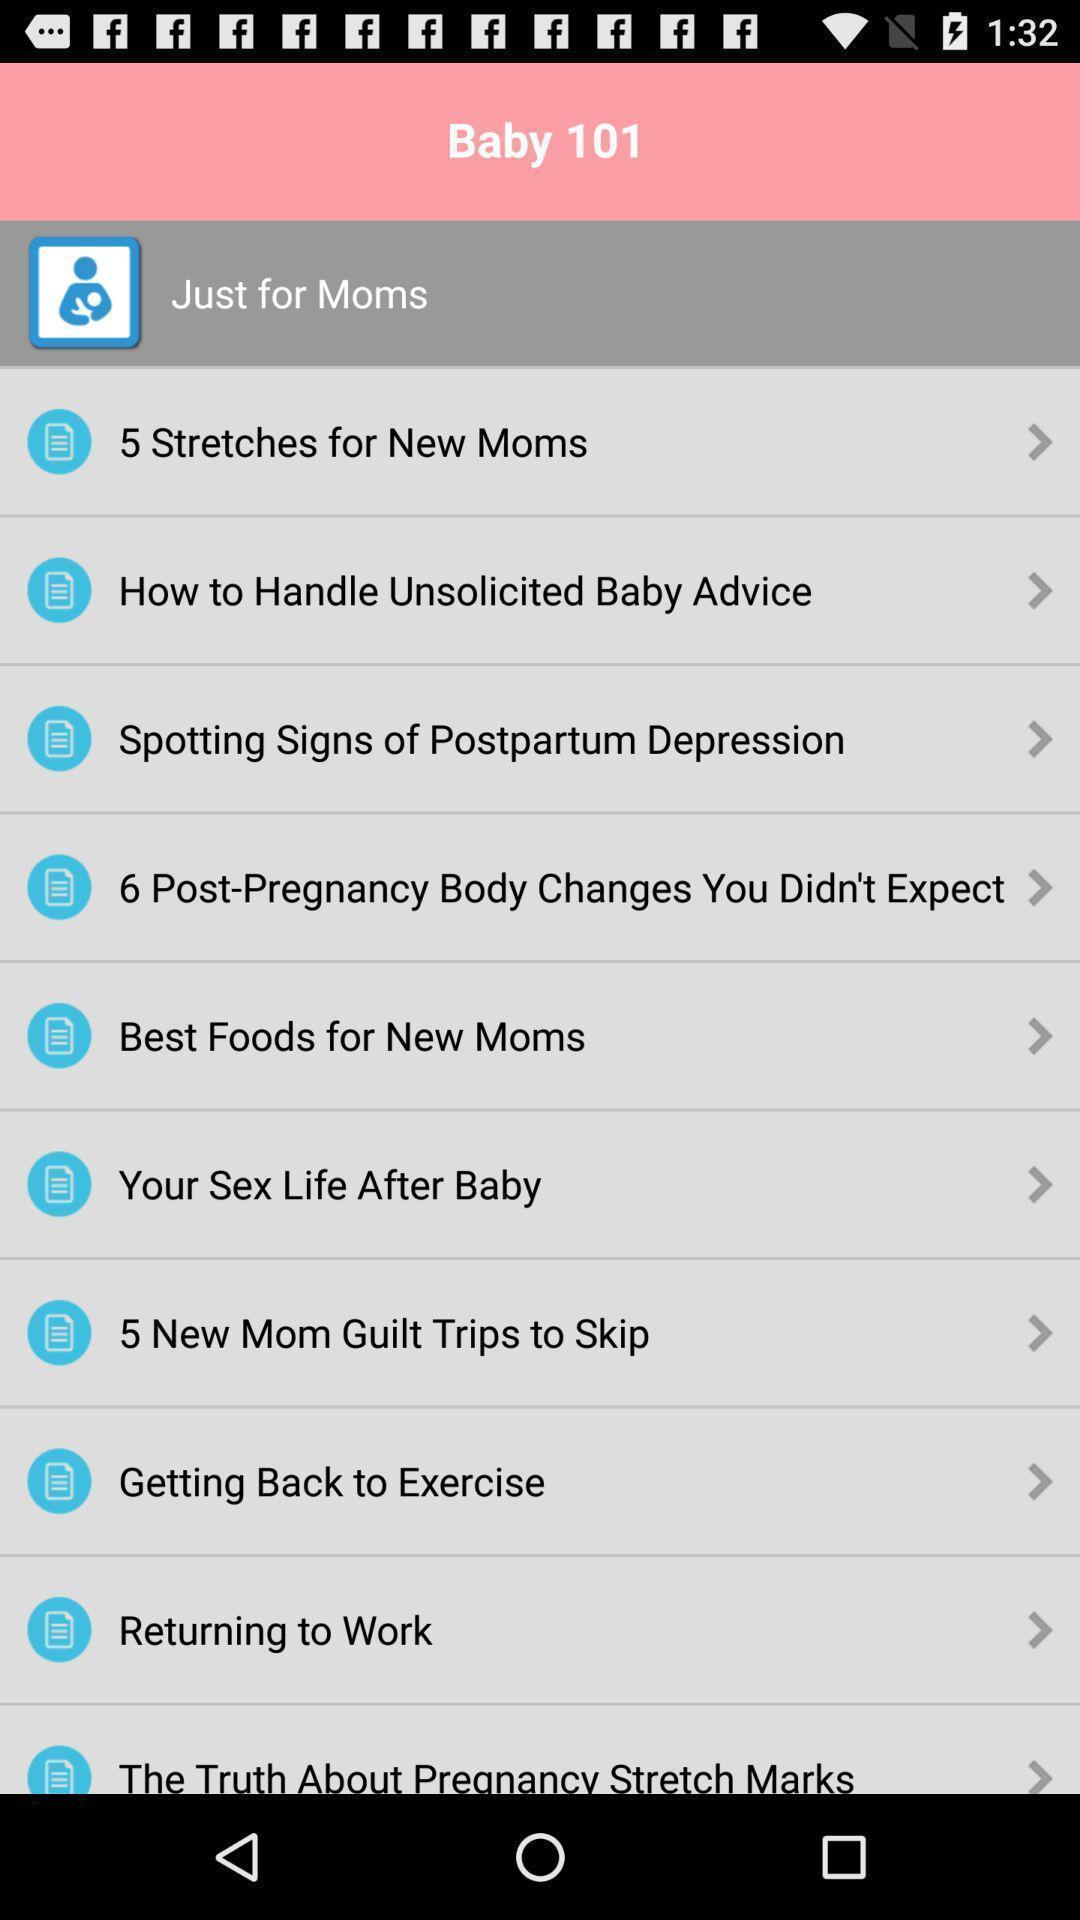Describe this image in words. Various tabs in the application regarding baby. 